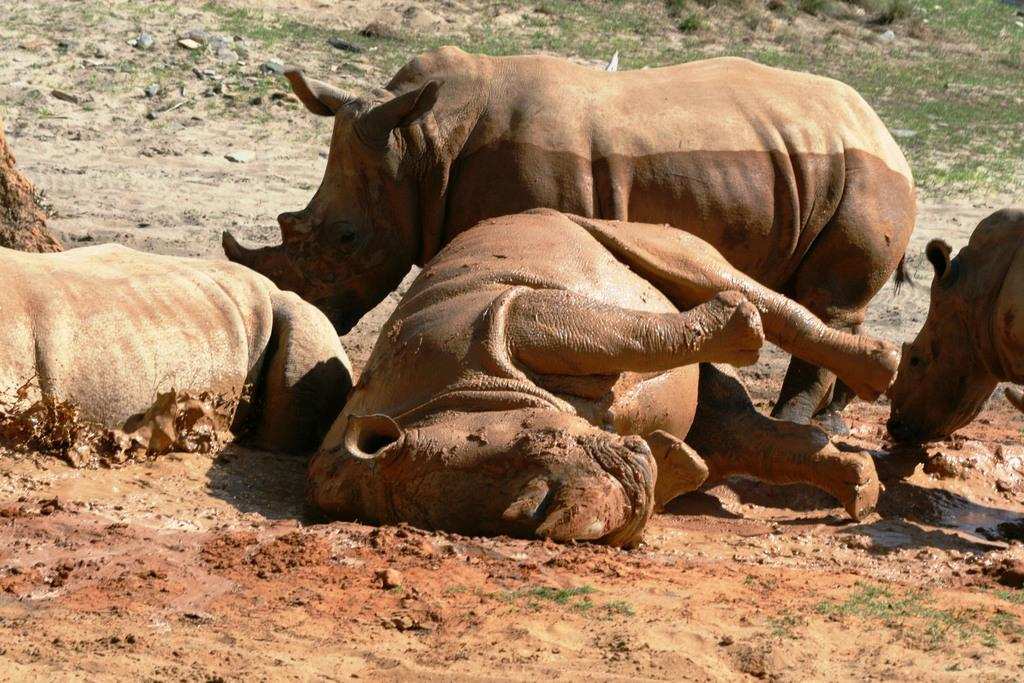What type of animals can be seen in the image? There are animals visible in the image. Where are the animals located in the image? The animals are on the mud. How are the animals positioned in the image? The animals are in the middle of the image. What type of throne can be seen in the image? There is no throne present in the image. What disease might the animals be suffering from in the image? There is no indication of any disease in the image; it only shows animals on the mud. 